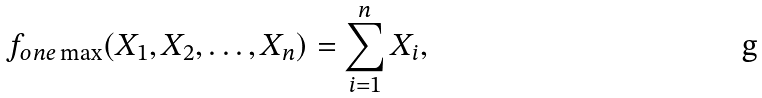Convert formula to latex. <formula><loc_0><loc_0><loc_500><loc_500>f _ { o n e \max } ( X _ { 1 } , X _ { 2 } , \dots , X _ { n } ) = \sum _ { i = 1 } ^ { n } X _ { i } ,</formula> 